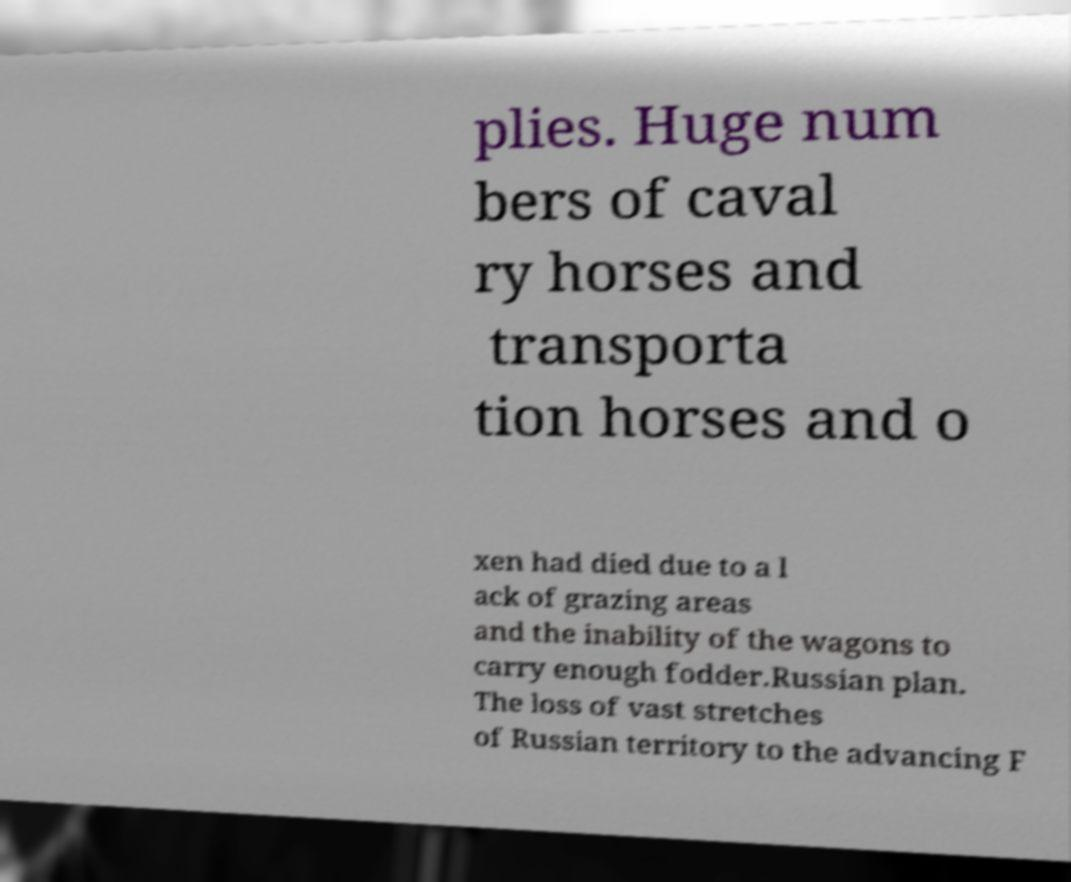There's text embedded in this image that I need extracted. Can you transcribe it verbatim? plies. Huge num bers of caval ry horses and transporta tion horses and o xen had died due to a l ack of grazing areas and the inability of the wagons to carry enough fodder.Russian plan. The loss of vast stretches of Russian territory to the advancing F 